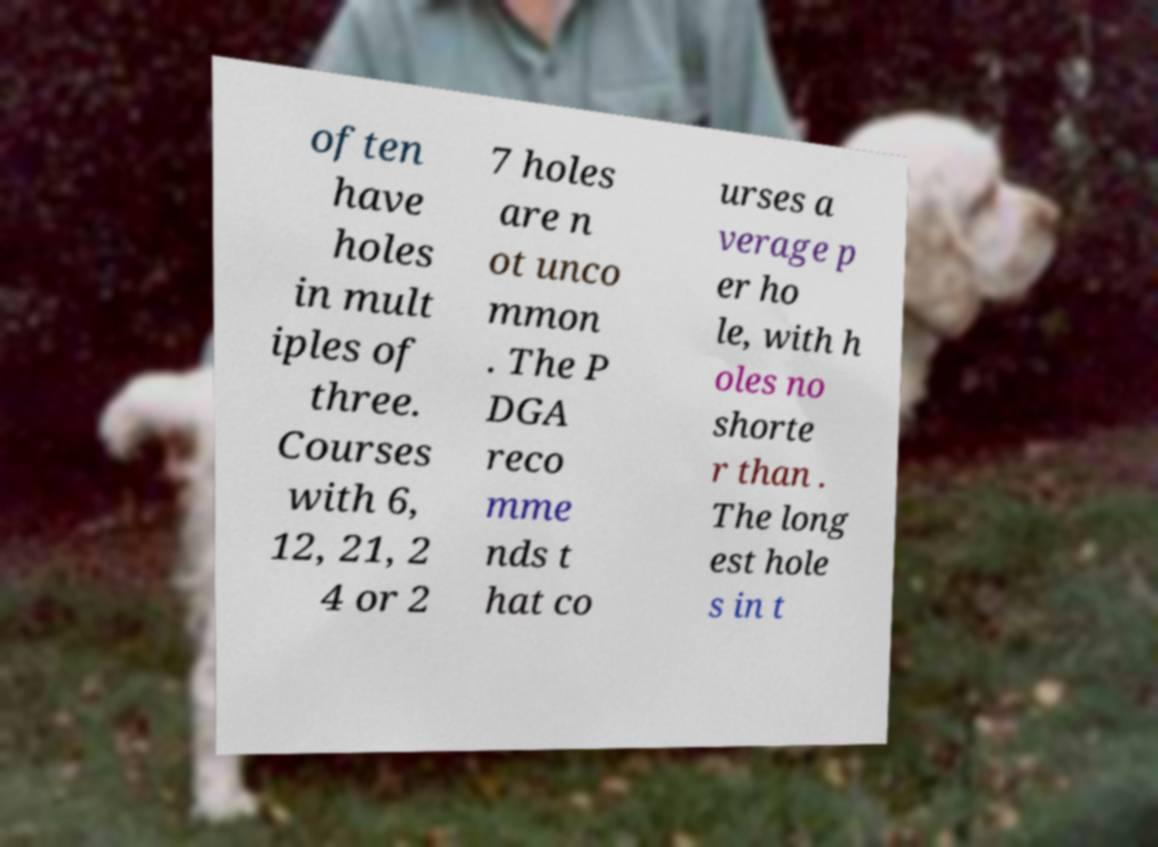Can you accurately transcribe the text from the provided image for me? often have holes in mult iples of three. Courses with 6, 12, 21, 2 4 or 2 7 holes are n ot unco mmon . The P DGA reco mme nds t hat co urses a verage p er ho le, with h oles no shorte r than . The long est hole s in t 